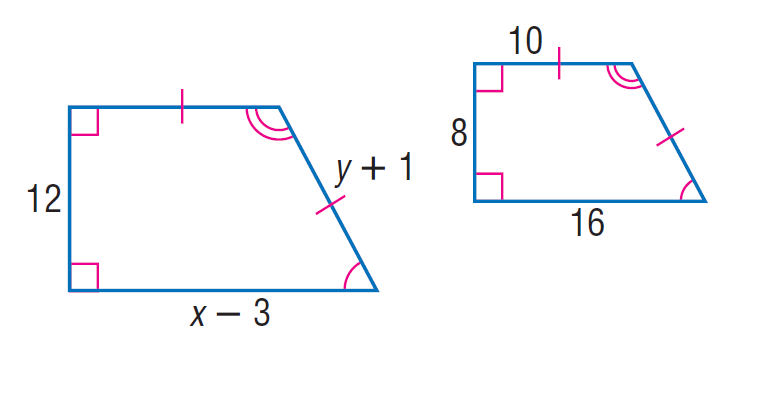Answer the mathemtical geometry problem and directly provide the correct option letter.
Question: Each pair of polygons is similar. Find y.
Choices: A: 12 B: 14 C: 20 D: 88 B 